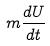Convert formula to latex. <formula><loc_0><loc_0><loc_500><loc_500>m \frac { d U } { d t }</formula> 